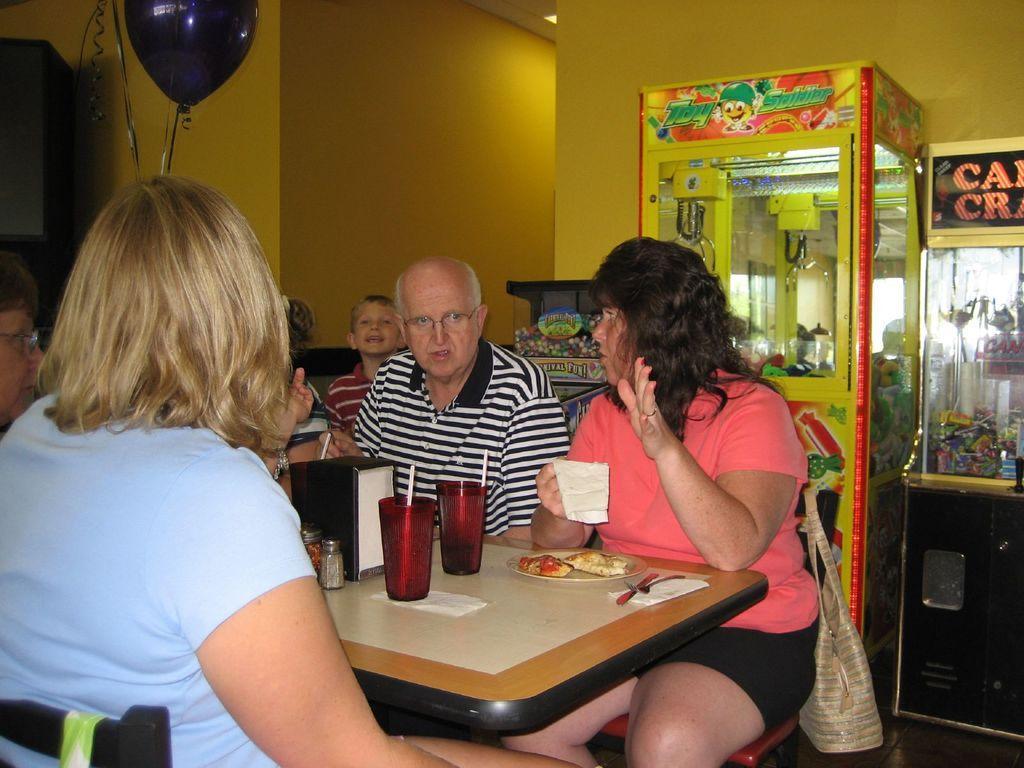Describe this image in one or two sentences. In the middle of the image there is a table, On the table there is a food and spoon and there is a glass. Surrounding the table few people are sitting. Top left side of the image there is a balloon. Behind the balloon there is a wall. Bottom right side of the image there are something. 